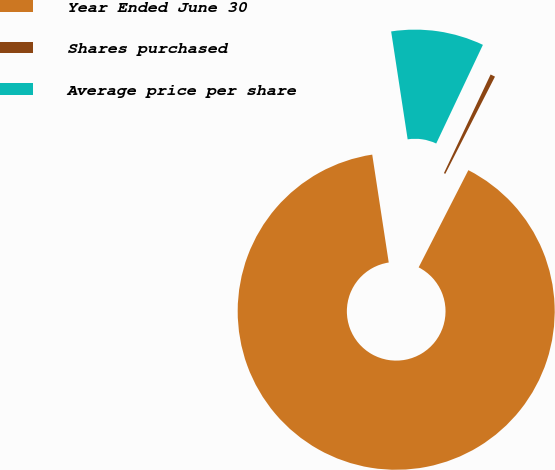Convert chart to OTSL. <chart><loc_0><loc_0><loc_500><loc_500><pie_chart><fcel>Year Ended June 30<fcel>Shares purchased<fcel>Average price per share<nl><fcel>90.06%<fcel>0.49%<fcel>9.45%<nl></chart> 